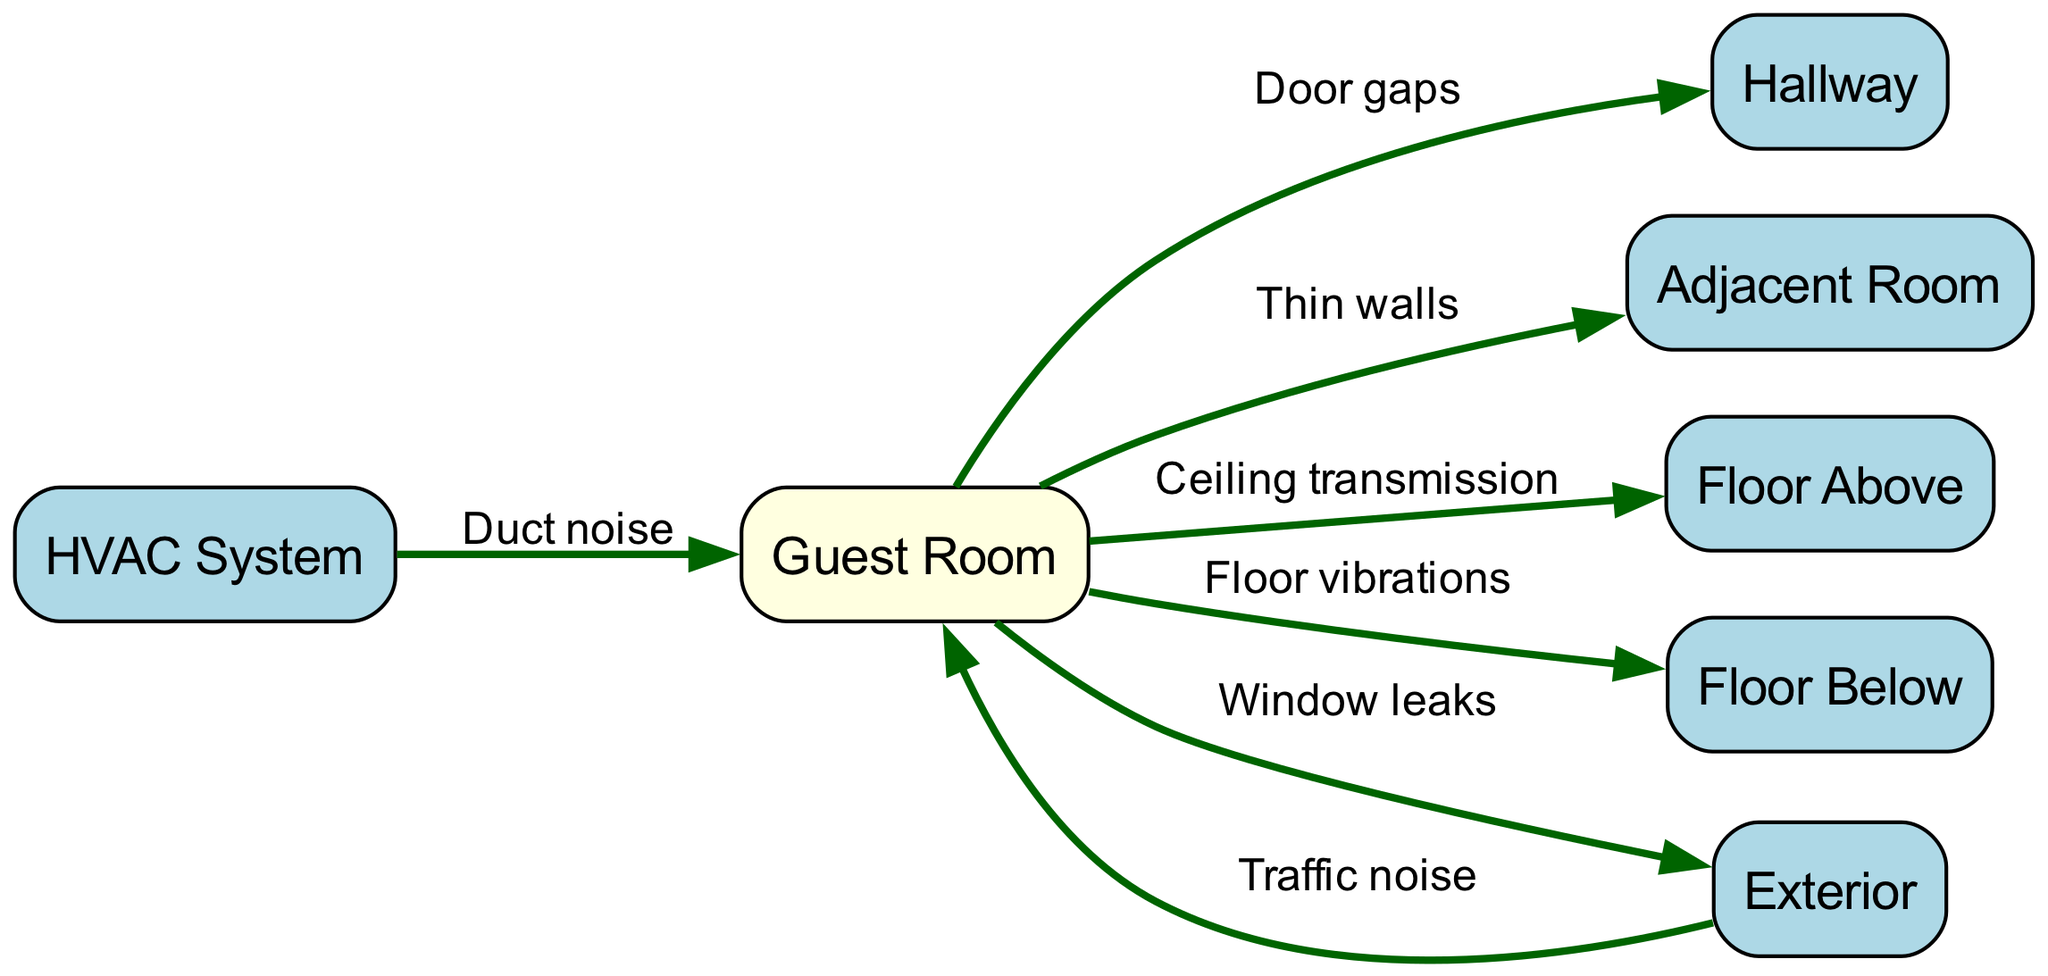How many nodes are present in the diagram? The diagram includes a total of seven nodes: Guest Room, Hallway, Adjacent Room, Floor Above, Floor Below, Exterior, and HVAC System.
Answer: 7 What is the relationship between the Guest Room and Hallway? The edge labeled "Door gaps" connects the Guest Room to the Hallway, indicating how sound can transmit through the gaps around the doors.
Answer: Door gaps Which node connects to the Guest Room through duct noise? The diagram shows an edge labeled "Duct noise" from the HVAC System to the Guest Room, indicating that noise can pass through the HVAC duct system.
Answer: HVAC System How many edges are outgoing from the Guest Room? There are six outgoing edges from the Guest Room to the Hallway, Adjacent Room, Floor Above, Floor Below, Exterior, and HVAC System, indicating multiple sound transmission paths.
Answer: 6 What type of noise is transmitted from the Exterior to the Guest Room? An edge labeled "Traffic noise" connects the Exterior to the Guest Room, indicating that external traffic can contribute to noise levels within the guest room.
Answer: Traffic noise If a guest experiences noise from the Floor Below, which transmission path is responsible? The edge labeled "Floor vibrations" from the Guest Room to the Floor Below indicates that noise can be transmitted through vibrations in the floor structure.
Answer: Floor vibrations Which two nodes show a direct connection related to thin walls? The edge labeled "Thin walls" directly connects the Guest Room to the Adjacent Room, indicating that sound can travel easily through the walls separating these two rooms.
Answer: Adjacent Room What are the two paths that lead to sound transmission due to the window? There are two edges that relate to the window: one labeled "Window leaks" from the Guest Room to the Exterior and another indirectly affecting sound from the Exterior.
Answer: Window leaks Which node represents a potential source of mechanical noise within the Guest Room? The "HVAC System" node is present in the diagram, which represents a potential source of mechanical noise transmitted into the Guest Room via ducting.
Answer: HVAC System 